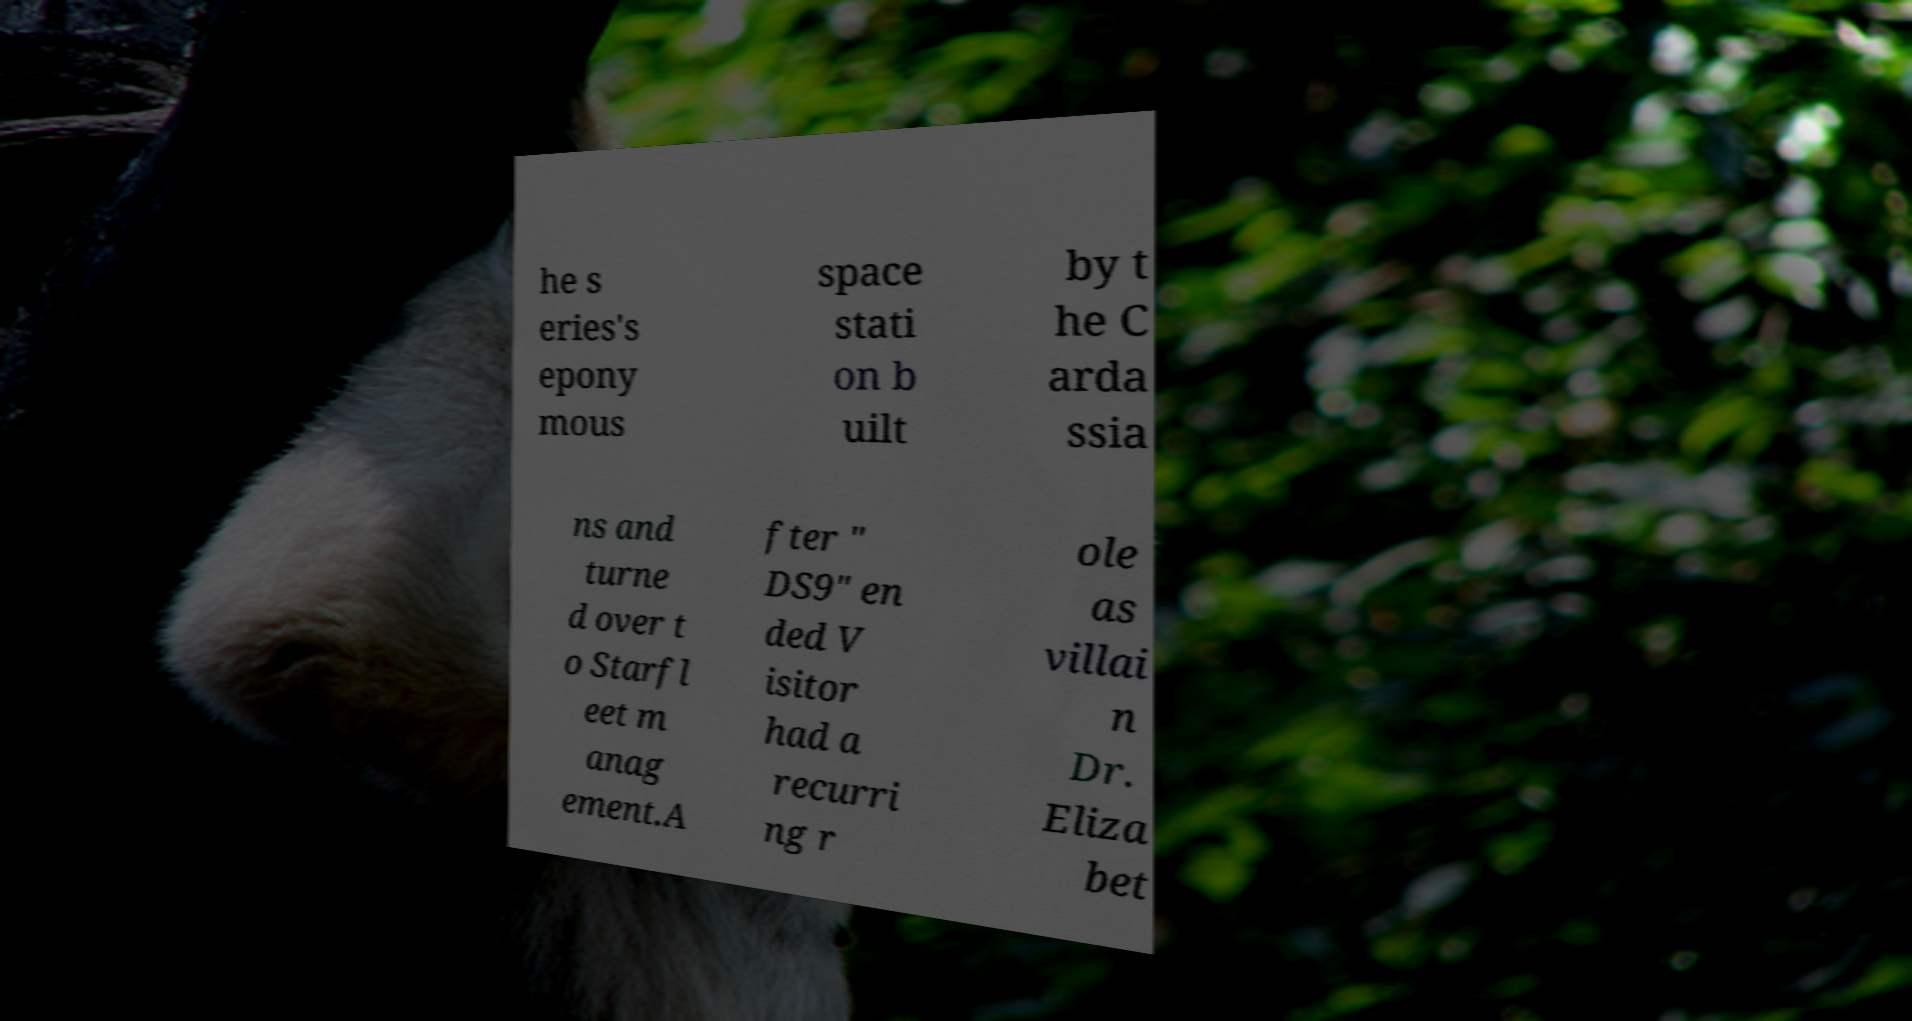Please identify and transcribe the text found in this image. he s eries's epony mous space stati on b uilt by t he C arda ssia ns and turne d over t o Starfl eet m anag ement.A fter " DS9" en ded V isitor had a recurri ng r ole as villai n Dr. Eliza bet 